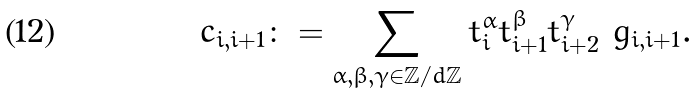Convert formula to latex. <formula><loc_0><loc_0><loc_500><loc_500>c _ { i , i + 1 } \colon = \sum _ { \alpha , \beta , \gamma \in \mathbb { Z } / d \mathbb { Z } } t _ { i } ^ { \alpha } t _ { i + 1 } ^ { \beta } t _ { i + 2 } ^ { \gamma } \ g _ { i , i + 1 } .</formula> 